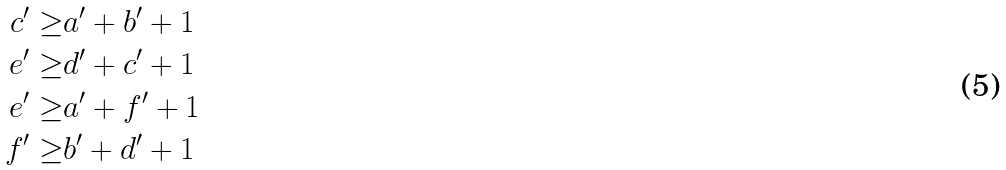Convert formula to latex. <formula><loc_0><loc_0><loc_500><loc_500>c ^ { \prime } \geq & a ^ { \prime } + b ^ { \prime } + 1 \\ e ^ { \prime } \geq & d ^ { \prime } + c ^ { \prime } + 1 \\ e ^ { \prime } \geq & a ^ { \prime } + f ^ { \prime } + 1 \\ f ^ { \prime } \geq & b ^ { \prime } + d ^ { \prime } + 1</formula> 